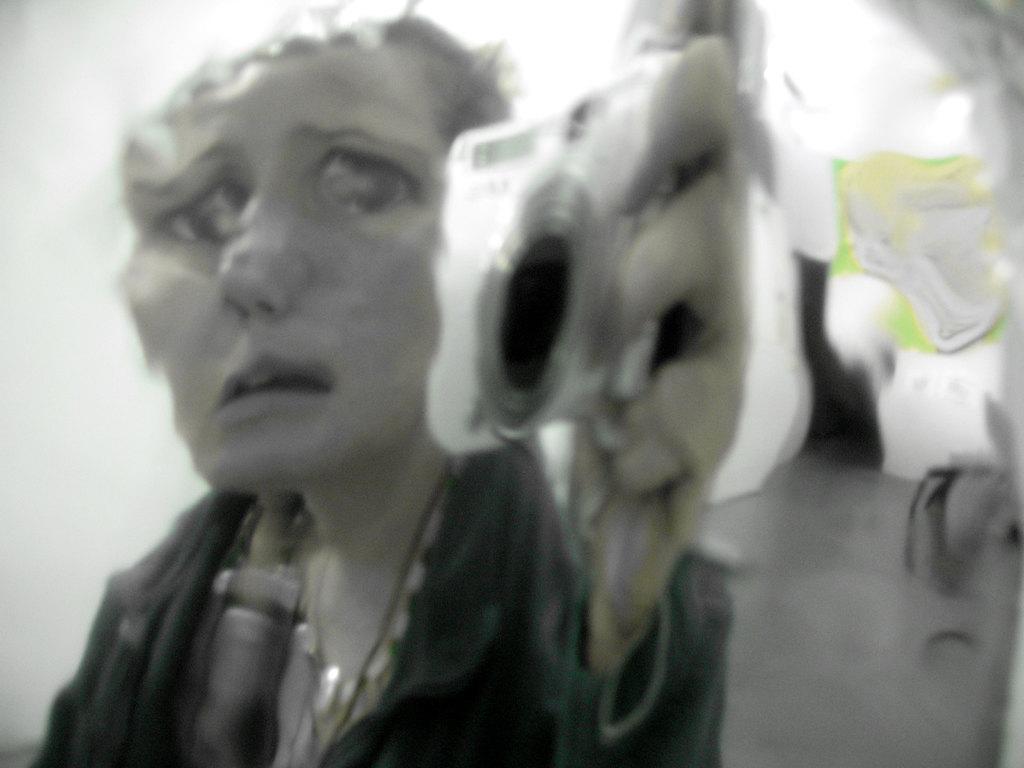Please provide a concise description of this image. In the image we can see a woman wearing clothes and holding a camera in hand. This is a floor. 